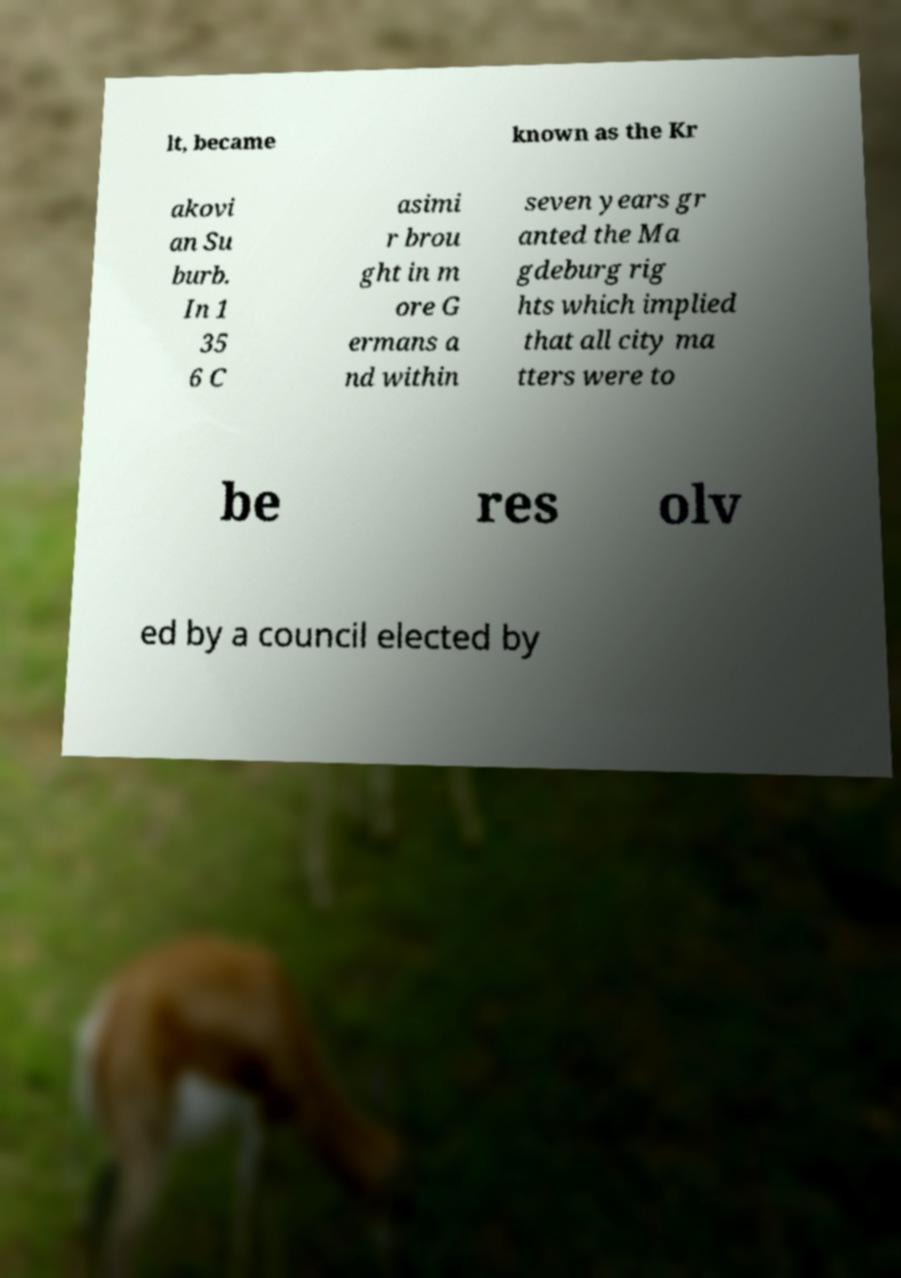I need the written content from this picture converted into text. Can you do that? lt, became known as the Kr akovi an Su burb. In 1 35 6 C asimi r brou ght in m ore G ermans a nd within seven years gr anted the Ma gdeburg rig hts which implied that all city ma tters were to be res olv ed by a council elected by 